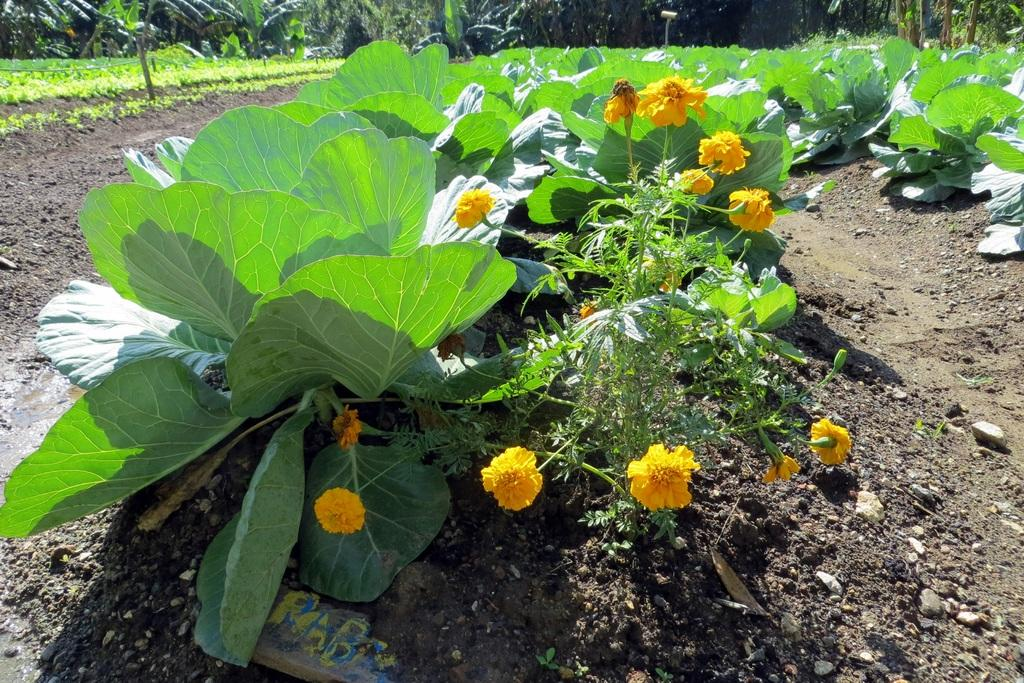What type of plant is visible in the image? There is a plant with flowers in the image. Are there any other plants in the image? Yes, there are other plants in the image. What can be seen in the background of the image? There are trees in the background of the image. What is on the ground in the image? There is soil and stones on the ground in the image. What song is the plant singing in the image? Plants do not sing songs, so there is no song being sung by the plant in the image. 